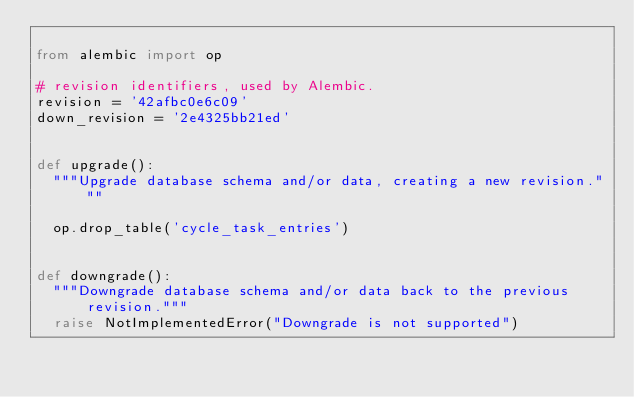<code> <loc_0><loc_0><loc_500><loc_500><_Python_>
from alembic import op

# revision identifiers, used by Alembic.
revision = '42afbc0e6c09'
down_revision = '2e4325bb21ed'


def upgrade():
  """Upgrade database schema and/or data, creating a new revision."""

  op.drop_table('cycle_task_entries')


def downgrade():
  """Downgrade database schema and/or data back to the previous revision."""
  raise NotImplementedError("Downgrade is not supported")
</code> 